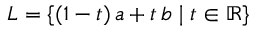<formula> <loc_0><loc_0><loc_500><loc_500>L = \{ ( 1 - t ) \, a + t \, b | t \in \mathbb { R } \}</formula> 